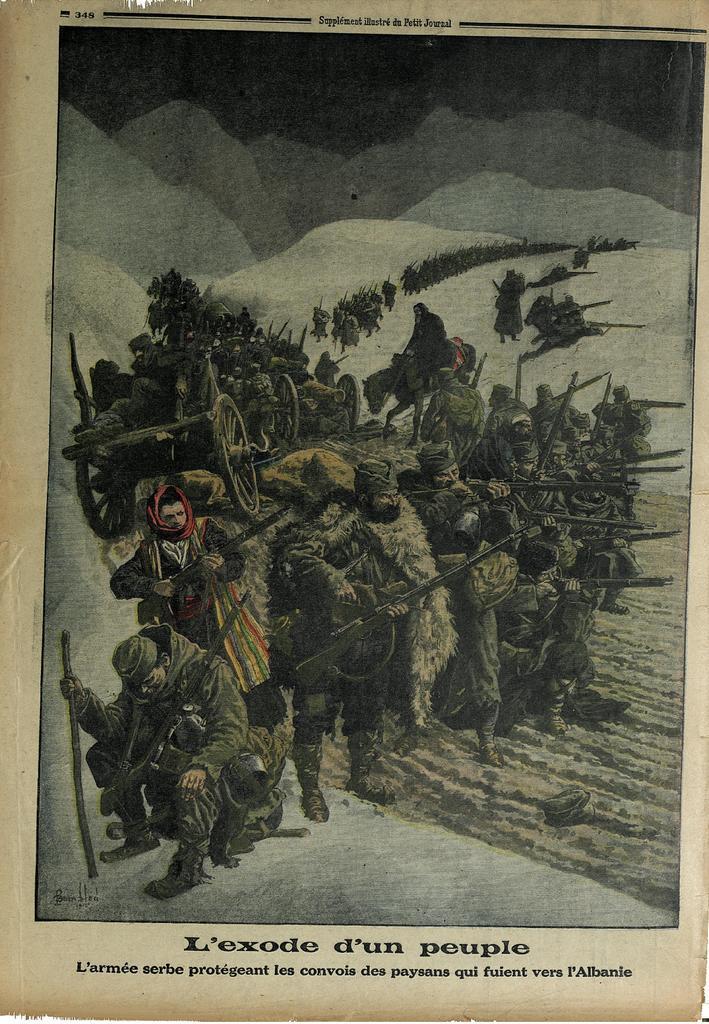How would you summarize this image in a sentence or two? In this image, we can see a poster with some images and text. 